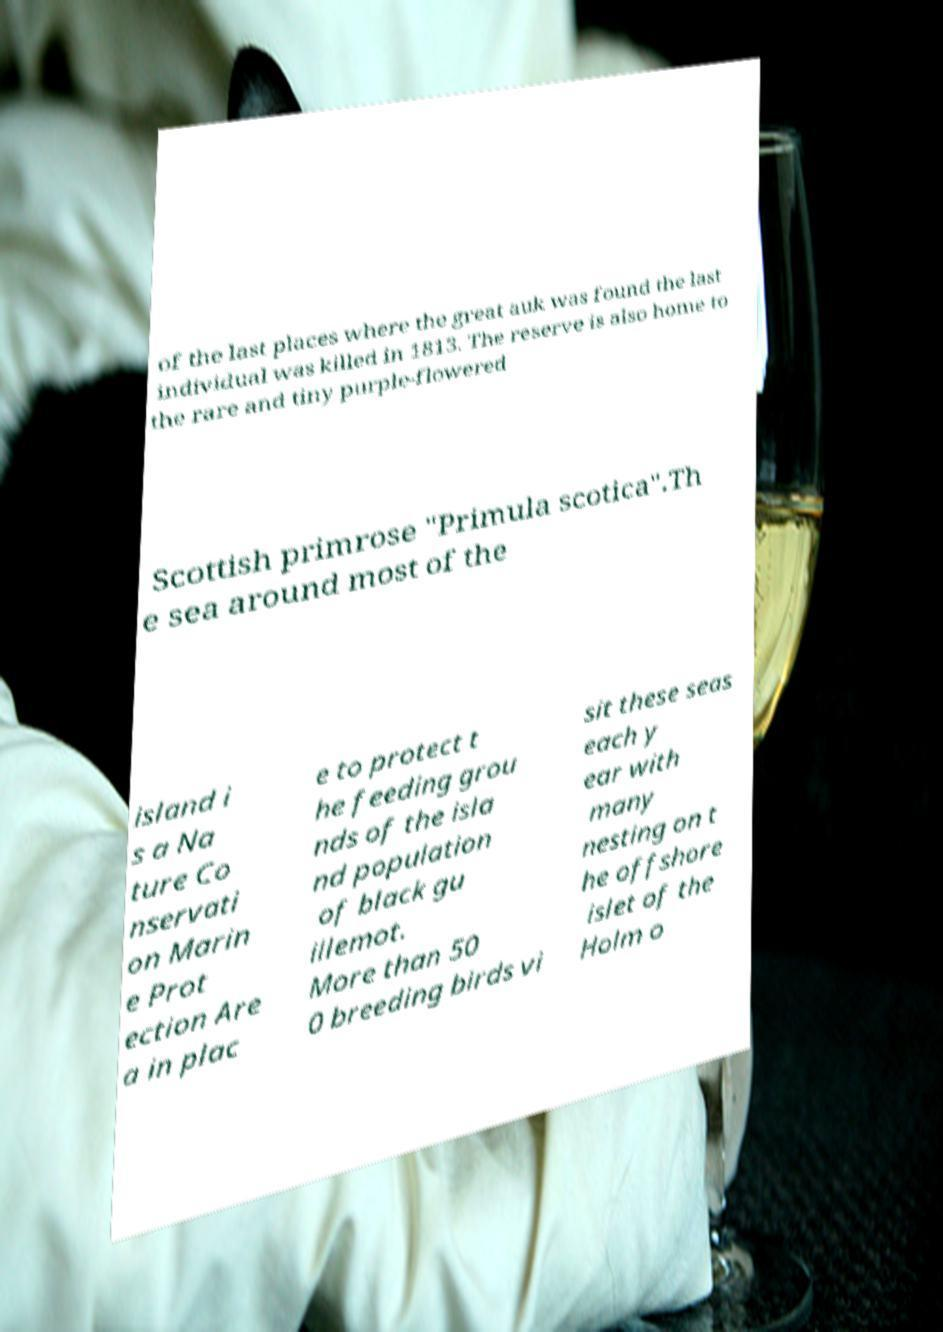There's text embedded in this image that I need extracted. Can you transcribe it verbatim? of the last places where the great auk was found the last individual was killed in 1813. The reserve is also home to the rare and tiny purple-flowered Scottish primrose "Primula scotica".Th e sea around most of the island i s a Na ture Co nservati on Marin e Prot ection Are a in plac e to protect t he feeding grou nds of the isla nd population of black gu illemot. More than 50 0 breeding birds vi sit these seas each y ear with many nesting on t he offshore islet of the Holm o 